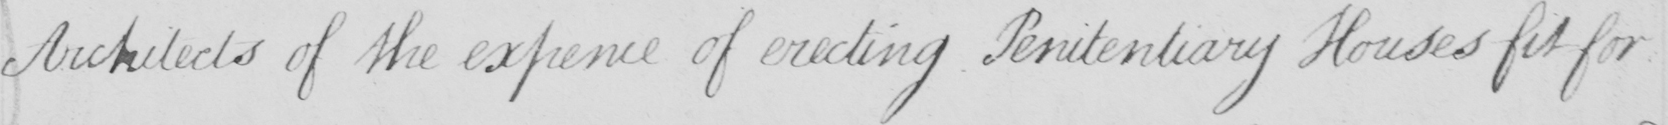Transcribe the text shown in this historical manuscript line. Architects of the expence of erecting Penitentiary Houses fit for 